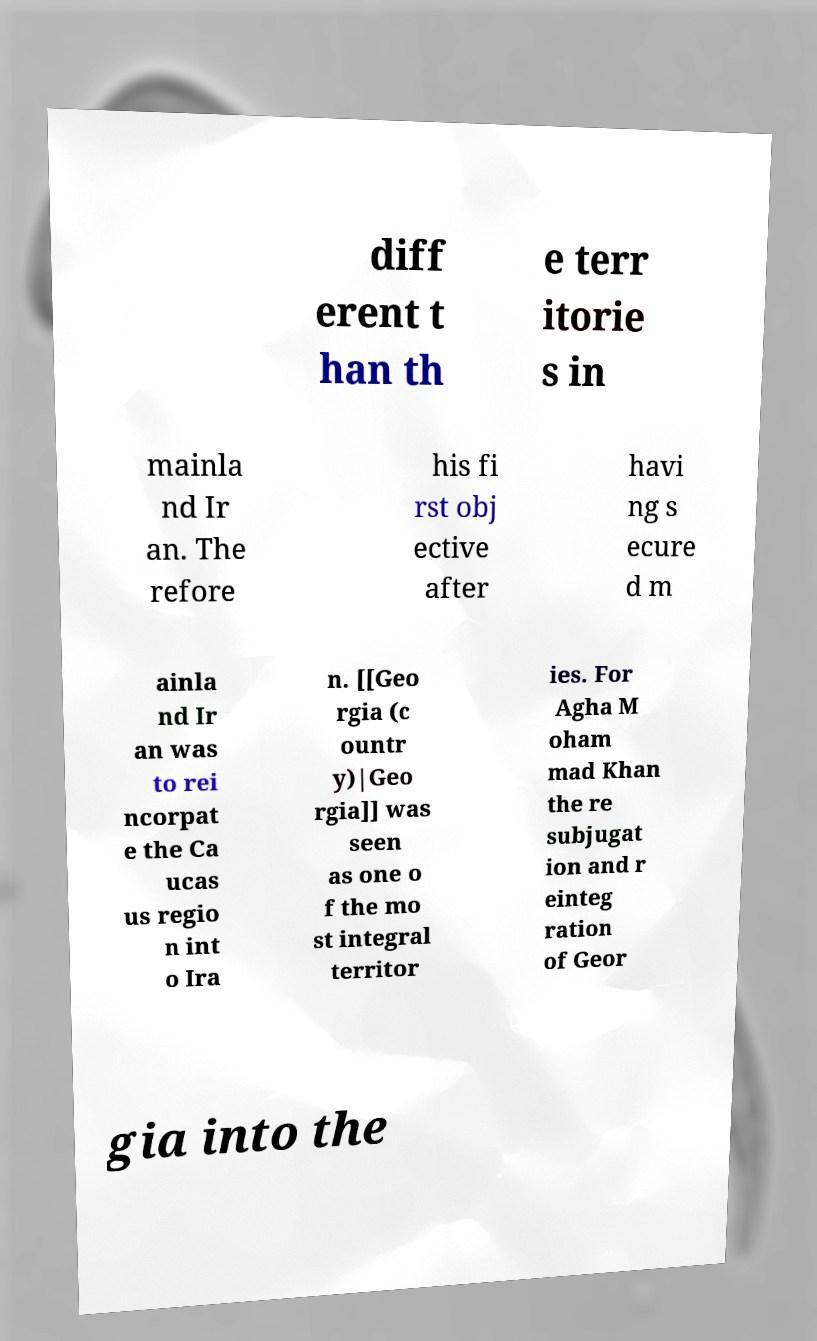I need the written content from this picture converted into text. Can you do that? diff erent t han th e terr itorie s in mainla nd Ir an. The refore his fi rst obj ective after havi ng s ecure d m ainla nd Ir an was to rei ncorpat e the Ca ucas us regio n int o Ira n. [[Geo rgia (c ountr y)|Geo rgia]] was seen as one o f the mo st integral territor ies. For Agha M oham mad Khan the re subjugat ion and r einteg ration of Geor gia into the 